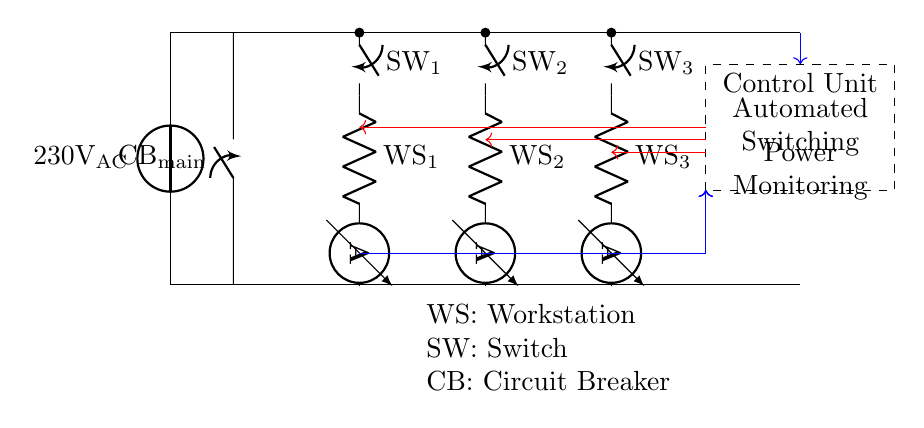What is the main voltage supply of this circuit? The main voltage supply in the circuit is indicated as 230 volts AC, which can be seen at the power source on the left.
Answer: 230 volts AC What are the components connected to the distribution bus? The components connected to the distribution bus are the circuit breaker and three workstations, as the distribution bus extends horizontally from the circuit breaker to the three switches for the workstations.
Answer: Circuit breaker and three workstations What is the function of the control unit in this circuit? The control unit has two main functions: automated switching and power monitoring, as labeled within the dashed rectangle.
Answer: Automated switching and power monitoring How is the current measured for each workstation? Each workstation has an ammeter connected in series after the resistor, allowing the current flowing through each workstation to be measured and displayed.
Answer: By an ammeter connected in series What happens if one of the workstation switches is turned off? If one of the workstation switches is turned off, the circuit path to that workstation is broken, preventing power from reaching it and effectively isolating it from the circuit without affecting others.
Answer: It isolates the workstation from the circuit How does the control unit receive current measurements? The control unit receives current measurements through connections that route the current from each workstation's ammeter to the control unit, which are represented by the blue arrows in the diagram.
Answer: Through the connections from ammeters, indicated by blue arrows 